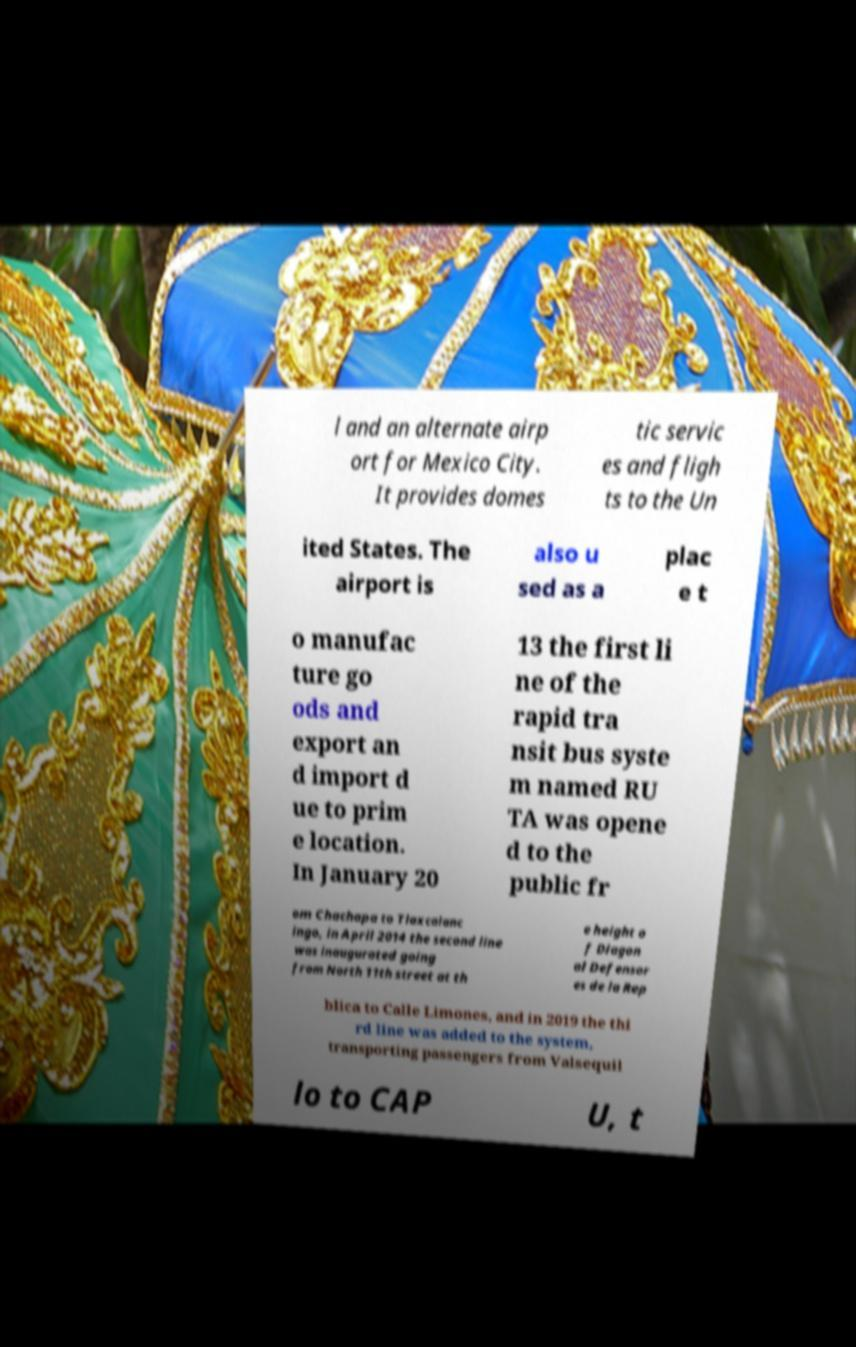There's text embedded in this image that I need extracted. Can you transcribe it verbatim? l and an alternate airp ort for Mexico City. It provides domes tic servic es and fligh ts to the Un ited States. The airport is also u sed as a plac e t o manufac ture go ods and export an d import d ue to prim e location. In January 20 13 the first li ne of the rapid tra nsit bus syste m named RU TA was opene d to the public fr om Chachapa to Tlaxcalanc ingo, in April 2014 the second line was inaugurated going from North 11th street at th e height o f Diagon al Defensor es de la Rep blica to Calle Limones, and in 2019 the thi rd line was added to the system, transporting passengers from Valsequil lo to CAP U, t 